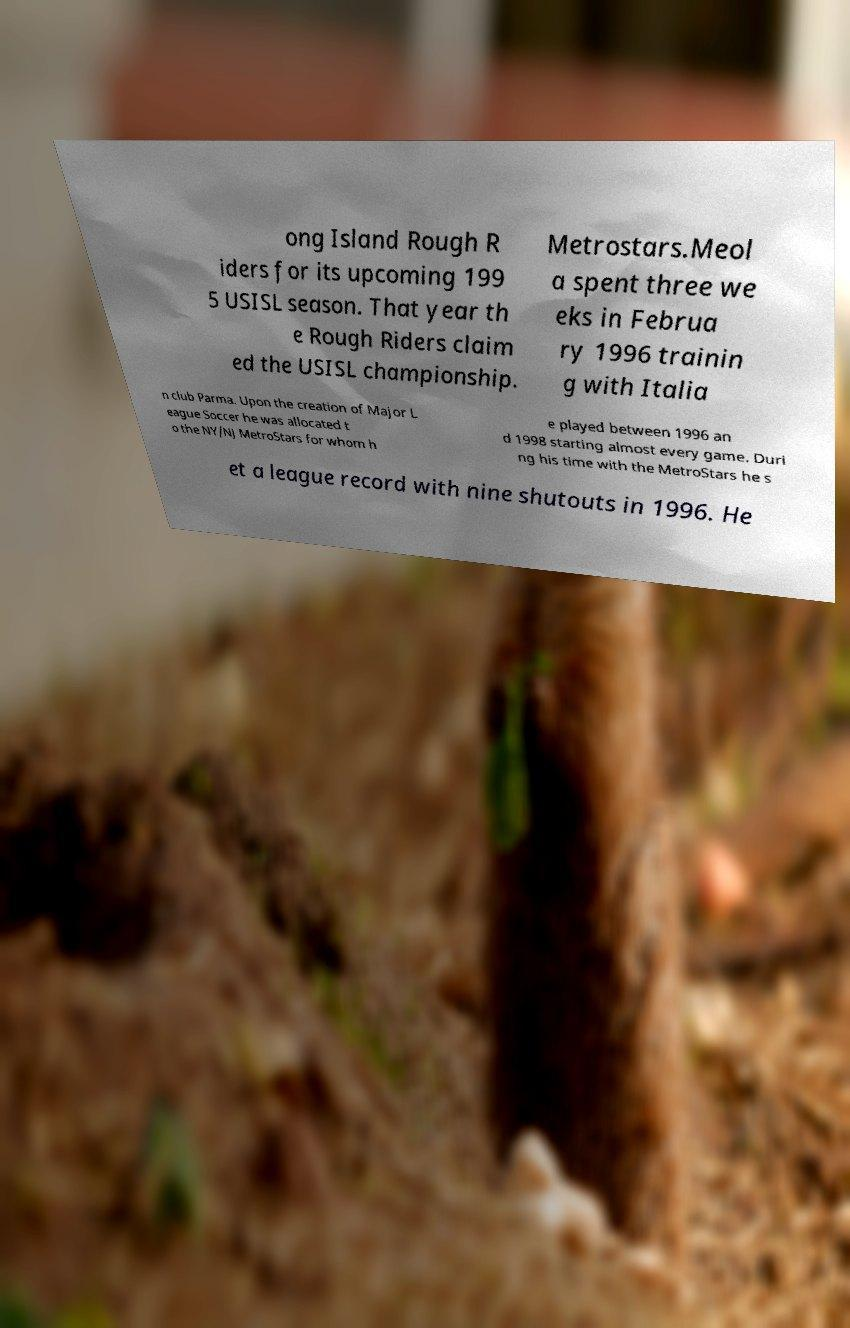Please read and relay the text visible in this image. What does it say? ong Island Rough R iders for its upcoming 199 5 USISL season. That year th e Rough Riders claim ed the USISL championship. Metrostars.Meol a spent three we eks in Februa ry 1996 trainin g with Italia n club Parma. Upon the creation of Major L eague Soccer he was allocated t o the NY/NJ MetroStars for whom h e played between 1996 an d 1998 starting almost every game. Duri ng his time with the MetroStars he s et a league record with nine shutouts in 1996. He 